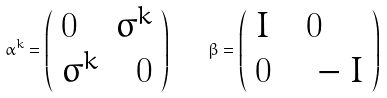Convert formula to latex. <formula><loc_0><loc_0><loc_500><loc_500>\alpha ^ { k } = \left ( \begin{array} { l l } 0 \quad \sigma ^ { k } \\ \sigma ^ { k } \quad 0 \end{array} \right ) \quad \beta = \left ( \begin{array} { l l } I \quad 0 \\ 0 \quad - I \end{array} \right )</formula> 